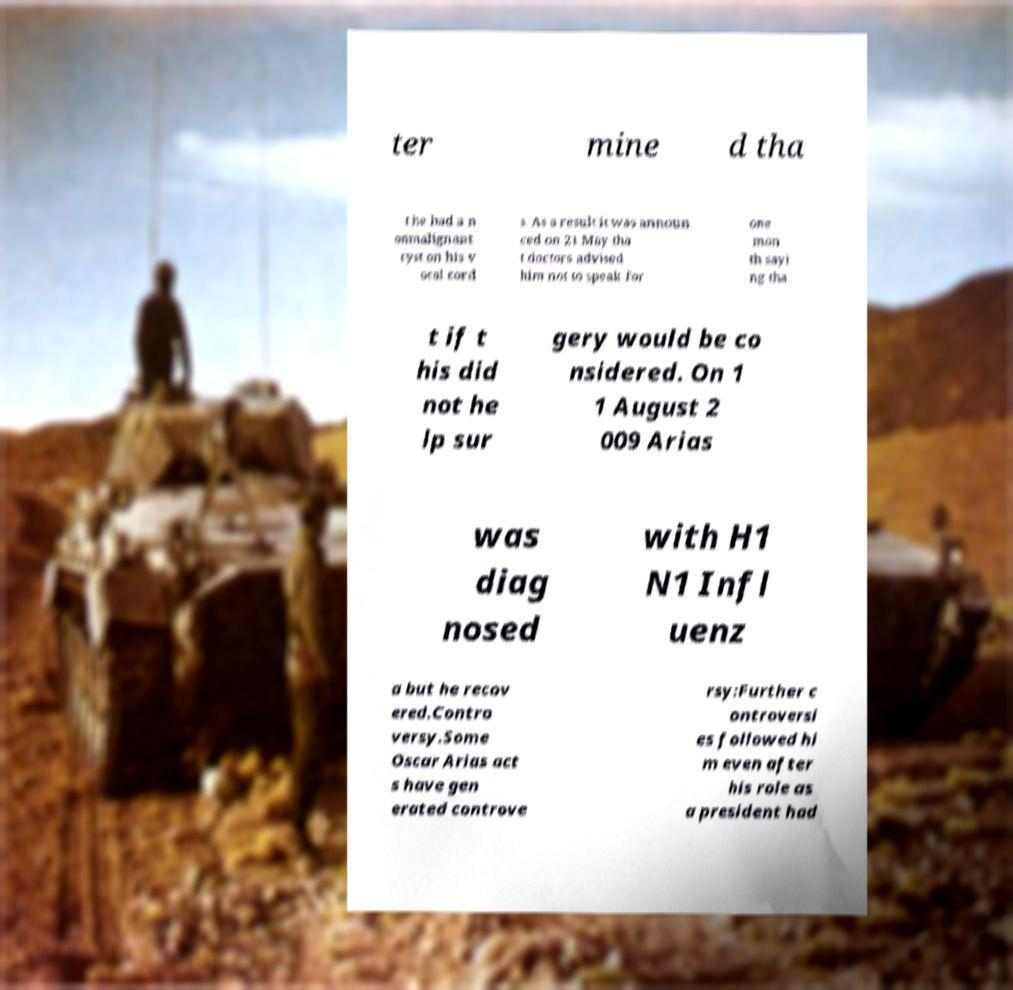Please read and relay the text visible in this image. What does it say? ter mine d tha t he had a n onmalignant cyst on his v ocal cord s. As a result it was announ ced on 21 May tha t doctors advised him not to speak for one mon th sayi ng tha t if t his did not he lp sur gery would be co nsidered. On 1 1 August 2 009 Arias was diag nosed with H1 N1 Infl uenz a but he recov ered.Contro versy.Some Oscar Arias act s have gen erated controve rsy:Further c ontroversi es followed hi m even after his role as a president had 